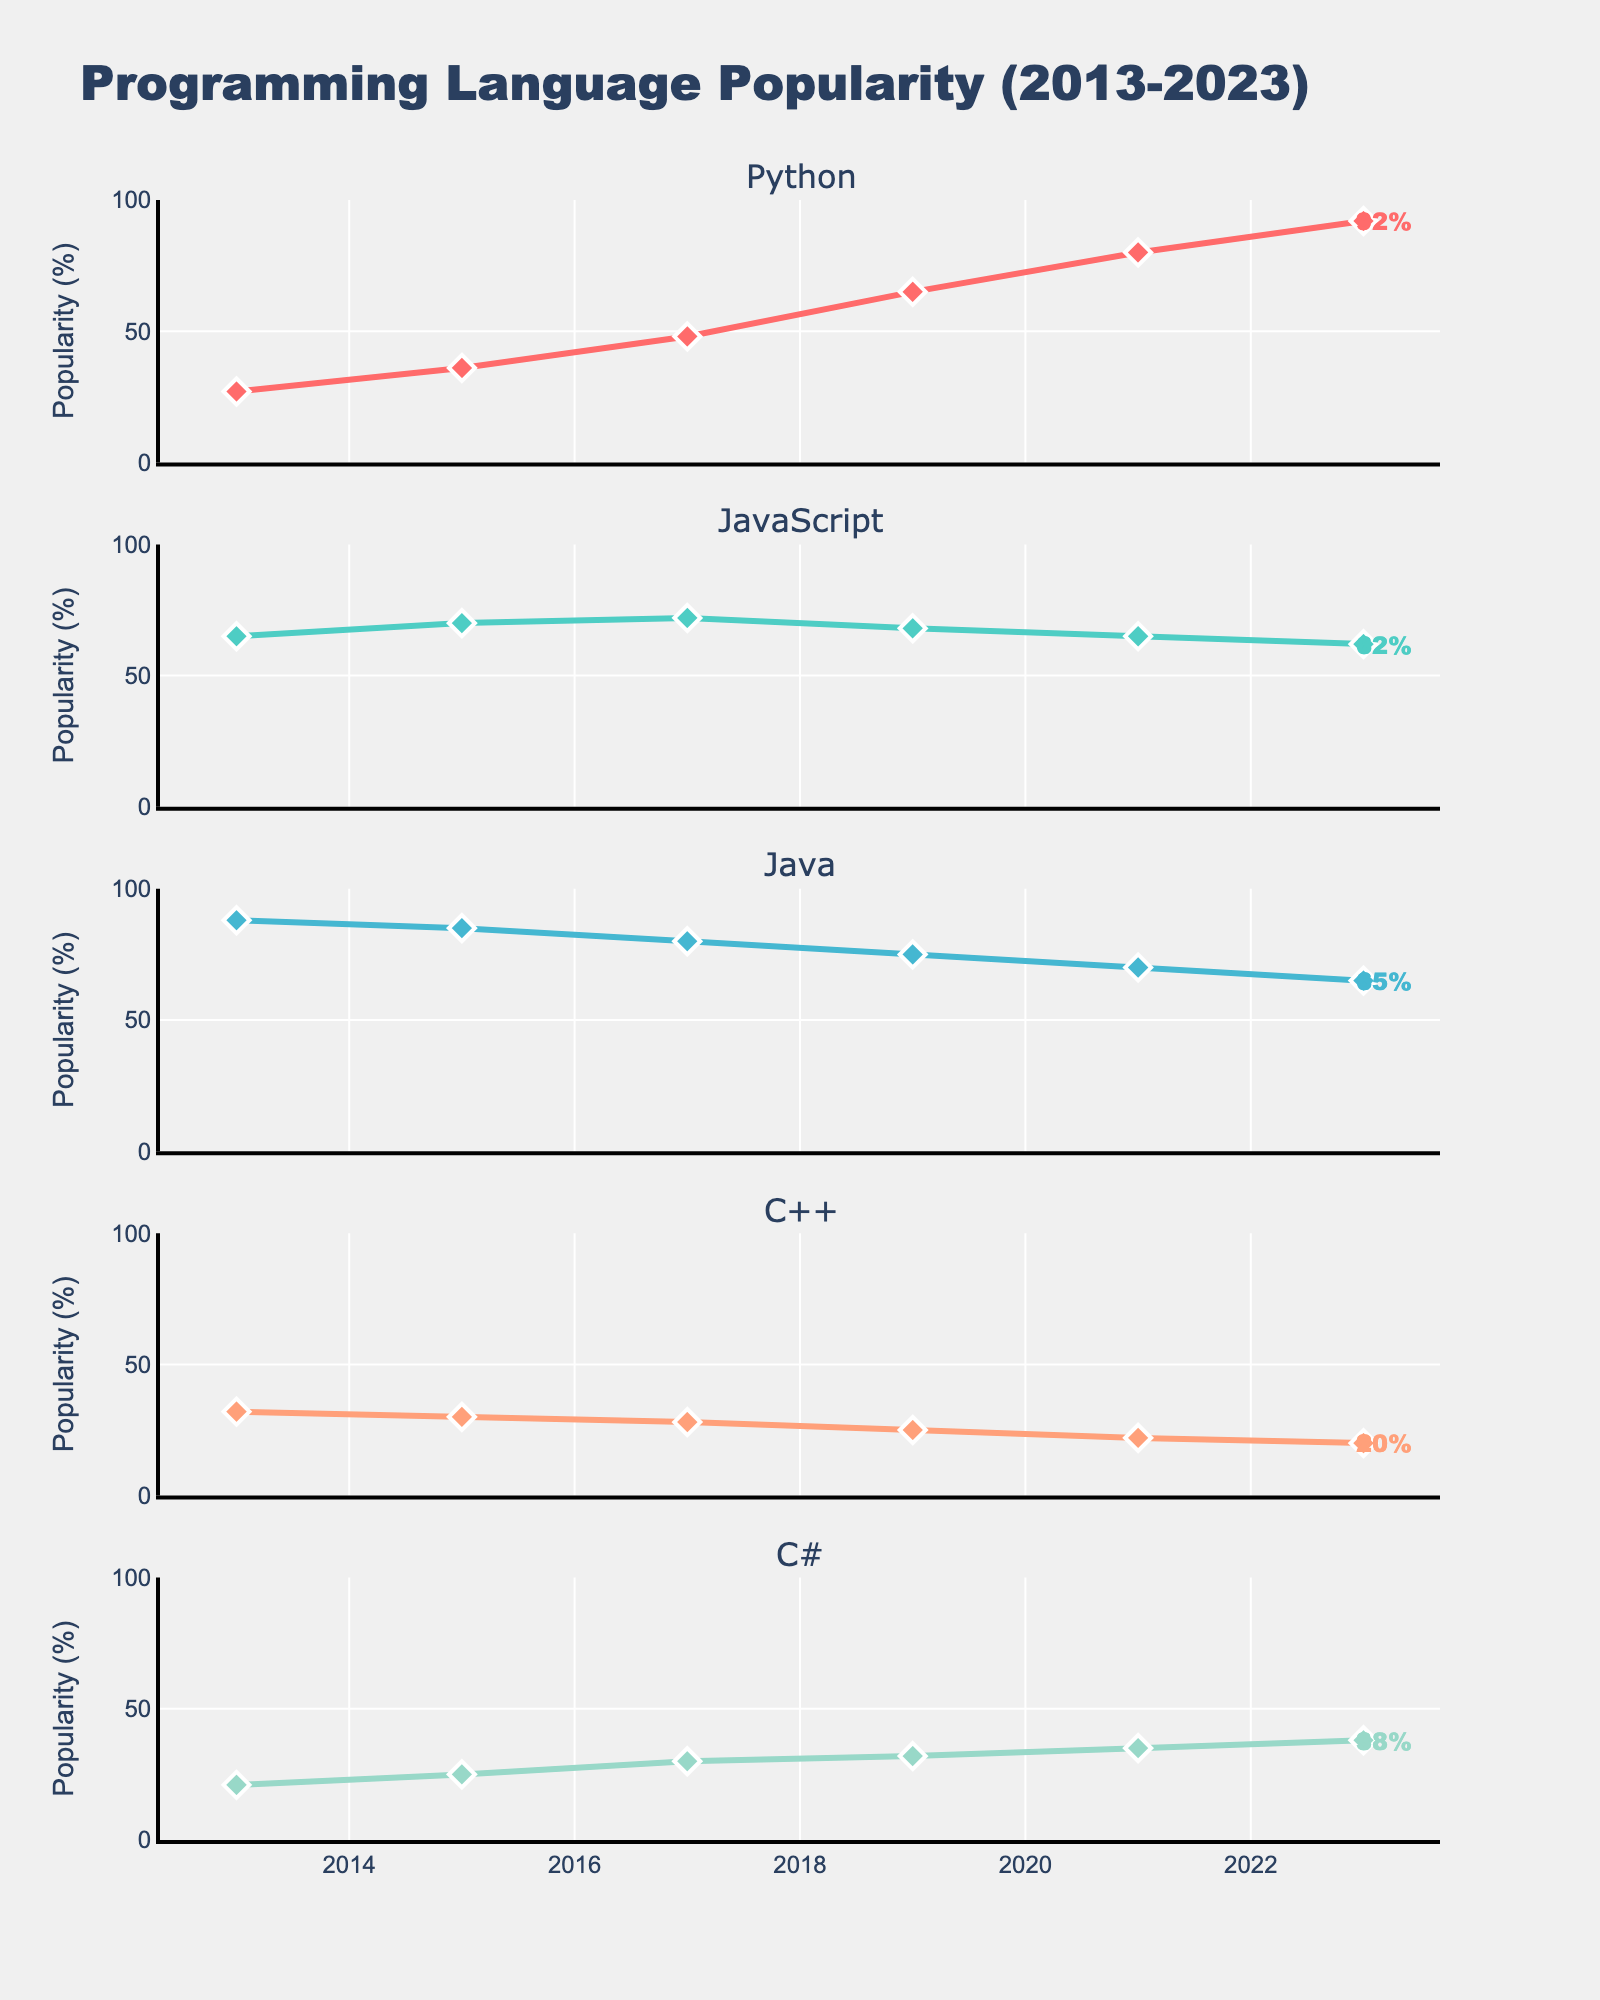What is the title of the figure? The title is typically found at the top center of the figure. In this case, it reads "Programming Language Popularity (2013-2023)"
Answer: Programming Language Popularity (2013-2023) Which programming language shows the highest popularity in 2023? By looking at the endpoint (2023) of each subplot, Python has the highest value at 92%
Answer: Python What is the trend of C++ popularity from 2013 to 2023? Refer to the C++ subplot and observe the line from 2013 to 2023. It shows a consistent decrease from 32% to 20%
Answer: Decreasing How many years are represented in the figure? Count the discrete year markers along the x-axis of any subplot. They are 2013, 2015, 2017, 2019, 2021, and 2023, totaling 6 years
Answer: 6 Which language had the smallest change in popularity from 2013 to 2023? For each language, calculate the absolute difference between the 2023 and 2013 values. JavaScript changes (65-62)=3%, which is the smallest compared to others
Answer: JavaScript What is the total increase in popularity of Python from 2013 to 2023? Subtract the value of Python in 2013 from its value in 2023: 92% - 27% = 65%
Answer: 65% Which programming languages had a popularity crossover between 2013 and 2023? Compare trends in all subplots. Python overtakes Java at some point between 2017 and 2019
Answer: Python and Java What was the popularity percentage of C# in 2019? Refer to the 2019 marker on the C# subplot. It is 32%
Answer: 32% Arrange the programming languages by their popularity in 2015 from highest to lowest. Look at the value for each language in 2015 and sort them: JavaScript (70%), Java (85%), Python (36%), C# (25%), C++ (30%)
Answer: JavaScript, Java, Python, C++, C# By how many percentage points did the popularity of JavaScript decline between 2017 and 2023? Find the difference in JavaScript's values between 2017 and 2023: 72% - 62% = 10%
Answer: 10% What was the average popularity of Java over the decade? Sum all the Java values from years 2013, 2015, 2017, 2019, 2021, and 2023, and divide by 6: (88 + 85 + 80 + 75 + 70 + 65) / 6 = 77.17%
Answer: 77.17% 